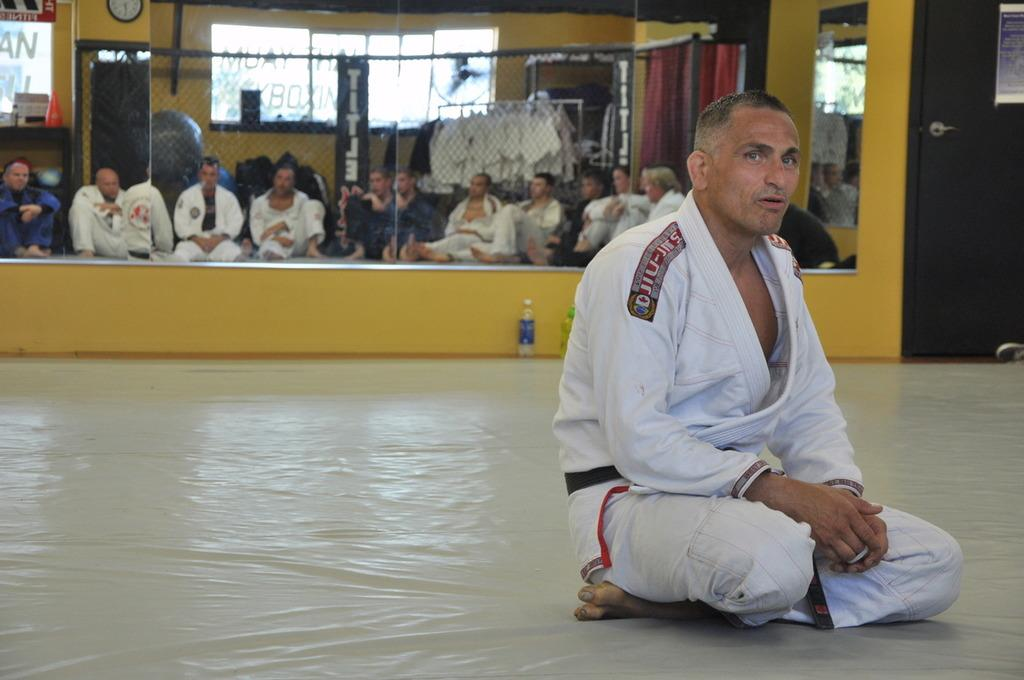Provide a one-sentence caption for the provided image. A martial arts instructor sitting in front of the class, with Japanese writing on his shoulders. 